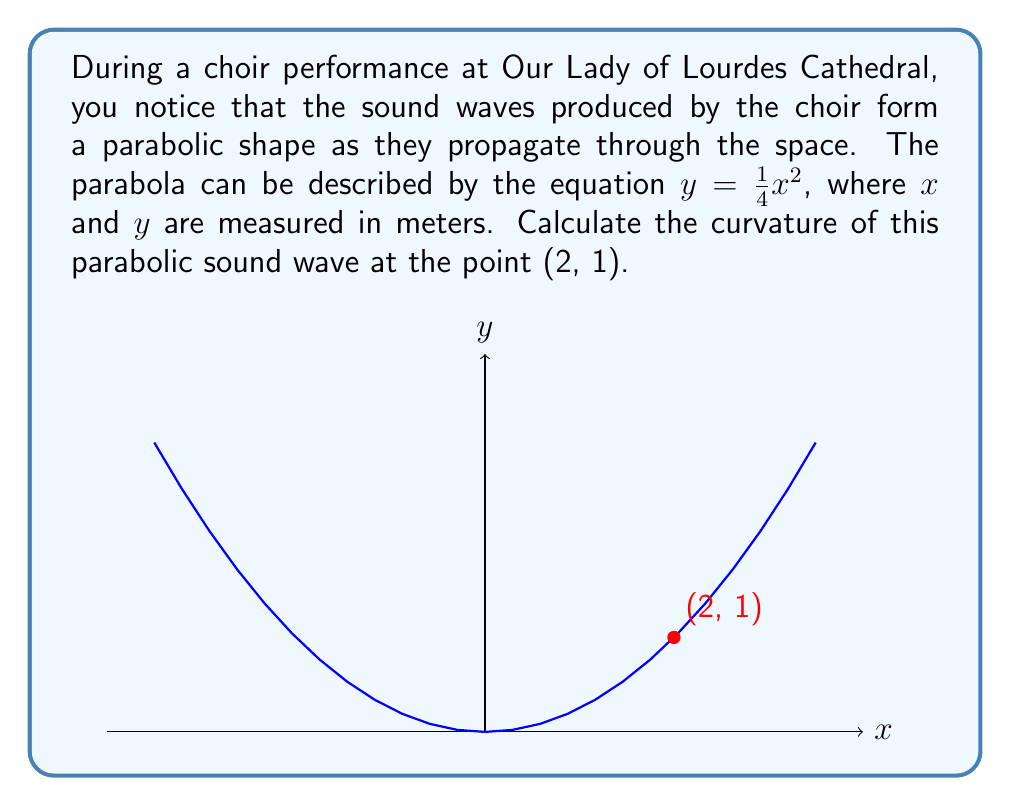Help me with this question. To determine the curvature of the parabolic sound wave, we'll follow these steps:

1) The general formula for curvature $K$ of a curve $y = f(x)$ at a point $(x, y)$ is:

   $$K = \frac{|f''(x)|}{(1 + [f'(x)]^2)^{3/2}}$$

2) For our parabola $y = \frac{1}{4}x^2$, we need to find $f'(x)$ and $f''(x)$:
   
   $f'(x) = \frac{1}{2}x$
   $f''(x) = \frac{1}{2}$

3) At the point (2, 1), we have $x = 2$. Let's substitute this into $f'(x)$:
   
   $f'(2) = \frac{1}{2} \cdot 2 = 1$

4) Now we can substitute all values into the curvature formula:

   $$K = \frac{|\frac{1}{2}|}{(1 + [1]^2)^{3/2}}$$

5) Simplify:
   
   $$K = \frac{0.5}{(1 + 1)^{3/2}} = \frac{0.5}{2^{3/2}} = \frac{0.5}{2\sqrt{2}}$$

6) This can be further simplified:

   $$K = \frac{1}{4\sqrt{2}} \approx 0.1768$$

Thus, the curvature of the parabolic sound wave at the point (2, 1) is $\frac{1}{4\sqrt{2}}$.
Answer: $\frac{1}{4\sqrt{2}}$ 